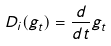<formula> <loc_0><loc_0><loc_500><loc_500>D _ { i } ( g _ { t } ) = \frac { d } { d t } g _ { t }</formula> 